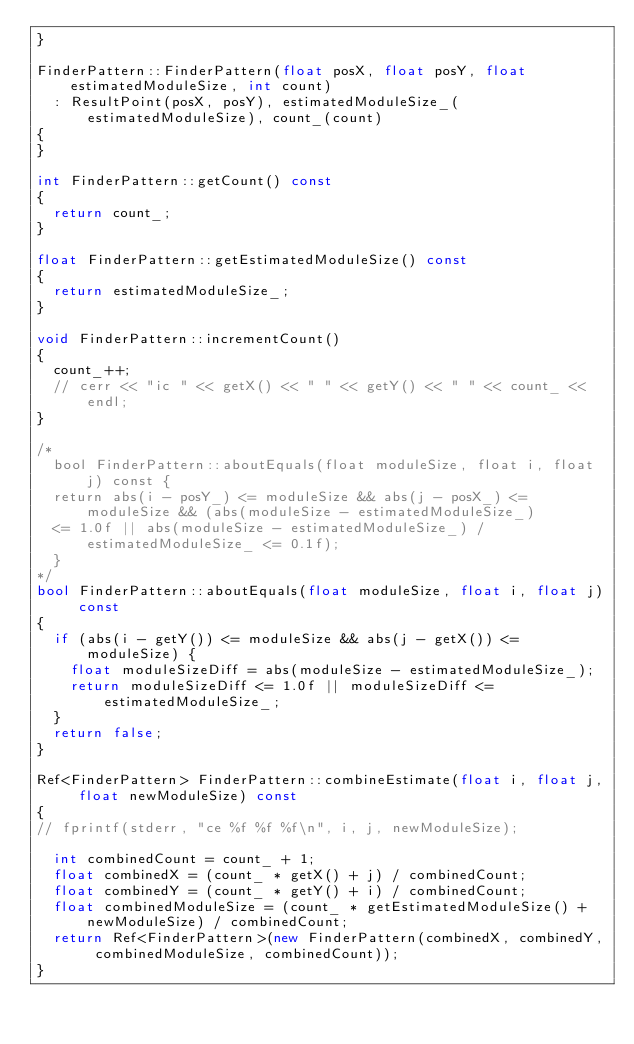<code> <loc_0><loc_0><loc_500><loc_500><_C++_>}

FinderPattern::FinderPattern(float posX, float posY, float estimatedModuleSize, int count)
	: ResultPoint(posX, posY), estimatedModuleSize_(estimatedModuleSize), count_(count)
{
}

int FinderPattern::getCount() const
{
	return count_;
}

float FinderPattern::getEstimatedModuleSize() const
{
	return estimatedModuleSize_;
}

void FinderPattern::incrementCount()
{
	count_++;
	// cerr << "ic " << getX() << " " << getY() << " " << count_ << endl;
}

/*
  bool FinderPattern::aboutEquals(float moduleSize, float i, float j) const {
  return abs(i - posY_) <= moduleSize && abs(j - posX_) <= moduleSize && (abs(moduleSize - estimatedModuleSize_)
  <= 1.0f || abs(moduleSize - estimatedModuleSize_) / estimatedModuleSize_ <= 0.1f);
  }
*/
bool FinderPattern::aboutEquals(float moduleSize, float i, float j) const
{
	if (abs(i - getY()) <= moduleSize && abs(j - getX()) <= moduleSize) {
		float moduleSizeDiff = abs(moduleSize - estimatedModuleSize_);
		return moduleSizeDiff <= 1.0f || moduleSizeDiff <= estimatedModuleSize_;
	}
	return false;
}

Ref<FinderPattern> FinderPattern::combineEstimate(float i, float j, float newModuleSize) const
{
// fprintf(stderr, "ce %f %f %f\n", i, j, newModuleSize);

	int combinedCount = count_ + 1;
	float combinedX = (count_ * getX() + j) / combinedCount;
	float combinedY = (count_ * getY() + i) / combinedCount;
	float combinedModuleSize = (count_ * getEstimatedModuleSize() + newModuleSize) / combinedCount;
	return Ref<FinderPattern>(new FinderPattern(combinedX, combinedY, combinedModuleSize, combinedCount));
}
</code> 